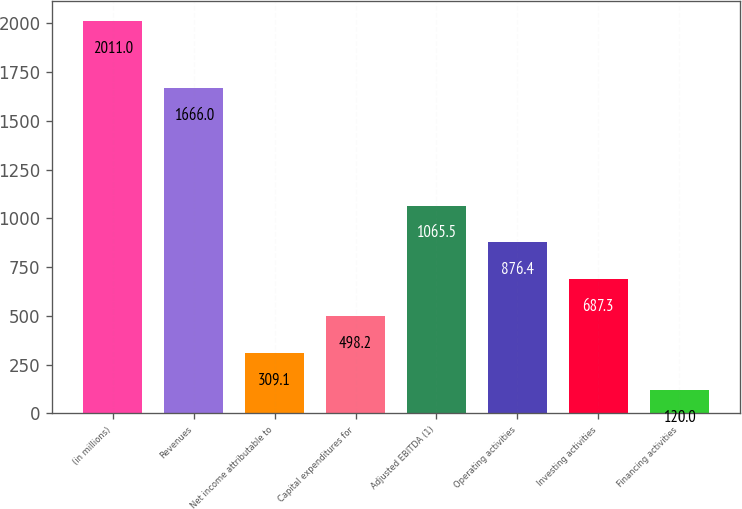Convert chart to OTSL. <chart><loc_0><loc_0><loc_500><loc_500><bar_chart><fcel>(in millions)<fcel>Revenues<fcel>Net income attributable to<fcel>Capital expenditures for<fcel>Adjusted EBITDA (1)<fcel>Operating activities<fcel>Investing activities<fcel>Financing activities<nl><fcel>2011<fcel>1666<fcel>309.1<fcel>498.2<fcel>1065.5<fcel>876.4<fcel>687.3<fcel>120<nl></chart> 